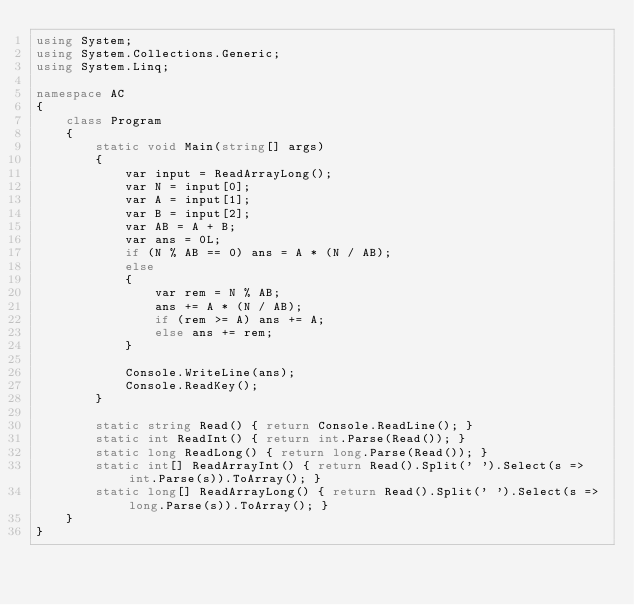Convert code to text. <code><loc_0><loc_0><loc_500><loc_500><_C#_>using System;
using System.Collections.Generic;
using System.Linq;

namespace AC
{
    class Program
    {
        static void Main(string[] args)
        {
            var input = ReadArrayLong();
            var N = input[0];
            var A = input[1];
            var B = input[2];
            var AB = A + B;
            var ans = 0L;
            if (N % AB == 0) ans = A * (N / AB);
            else
            {
                var rem = N % AB;
                ans += A * (N / AB);
                if (rem >= A) ans += A;
                else ans += rem;
            }

            Console.WriteLine(ans);
            Console.ReadKey();
        }

        static string Read() { return Console.ReadLine(); }
        static int ReadInt() { return int.Parse(Read()); }
        static long ReadLong() { return long.Parse(Read()); }
        static int[] ReadArrayInt() { return Read().Split(' ').Select(s => int.Parse(s)).ToArray(); }
        static long[] ReadArrayLong() { return Read().Split(' ').Select(s => long.Parse(s)).ToArray(); }
    }
}</code> 